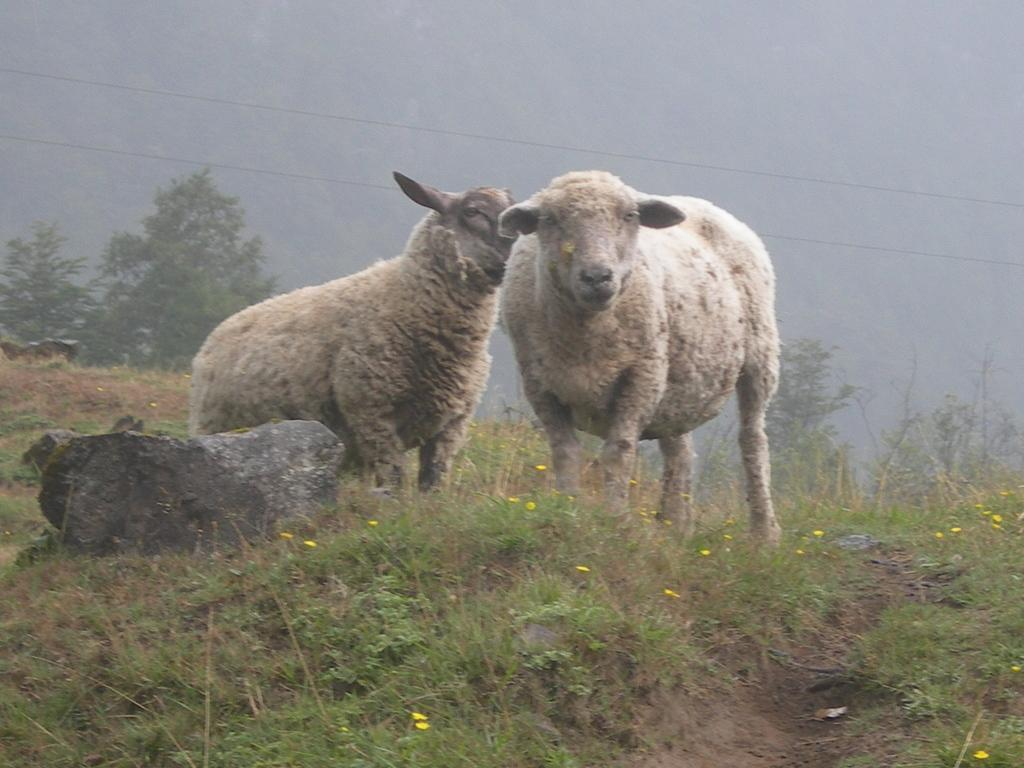What animals are present in the image? There are two sheep standing in the image. What type of vegetation can be seen at the bottom of the image? There are plants and flowers at the bottom of the image. What object is located on the left side of the image? There is a rock on the left side of the image. What can be seen in the distance in the image? Trees are visible in the background of the image. What type of cork can be seen in the image? There is no cork present in the image. What does the sheep's voice sound like in the image? The image is a still photograph and does not contain any sound, so it is not possible to determine the sheep's voice. 